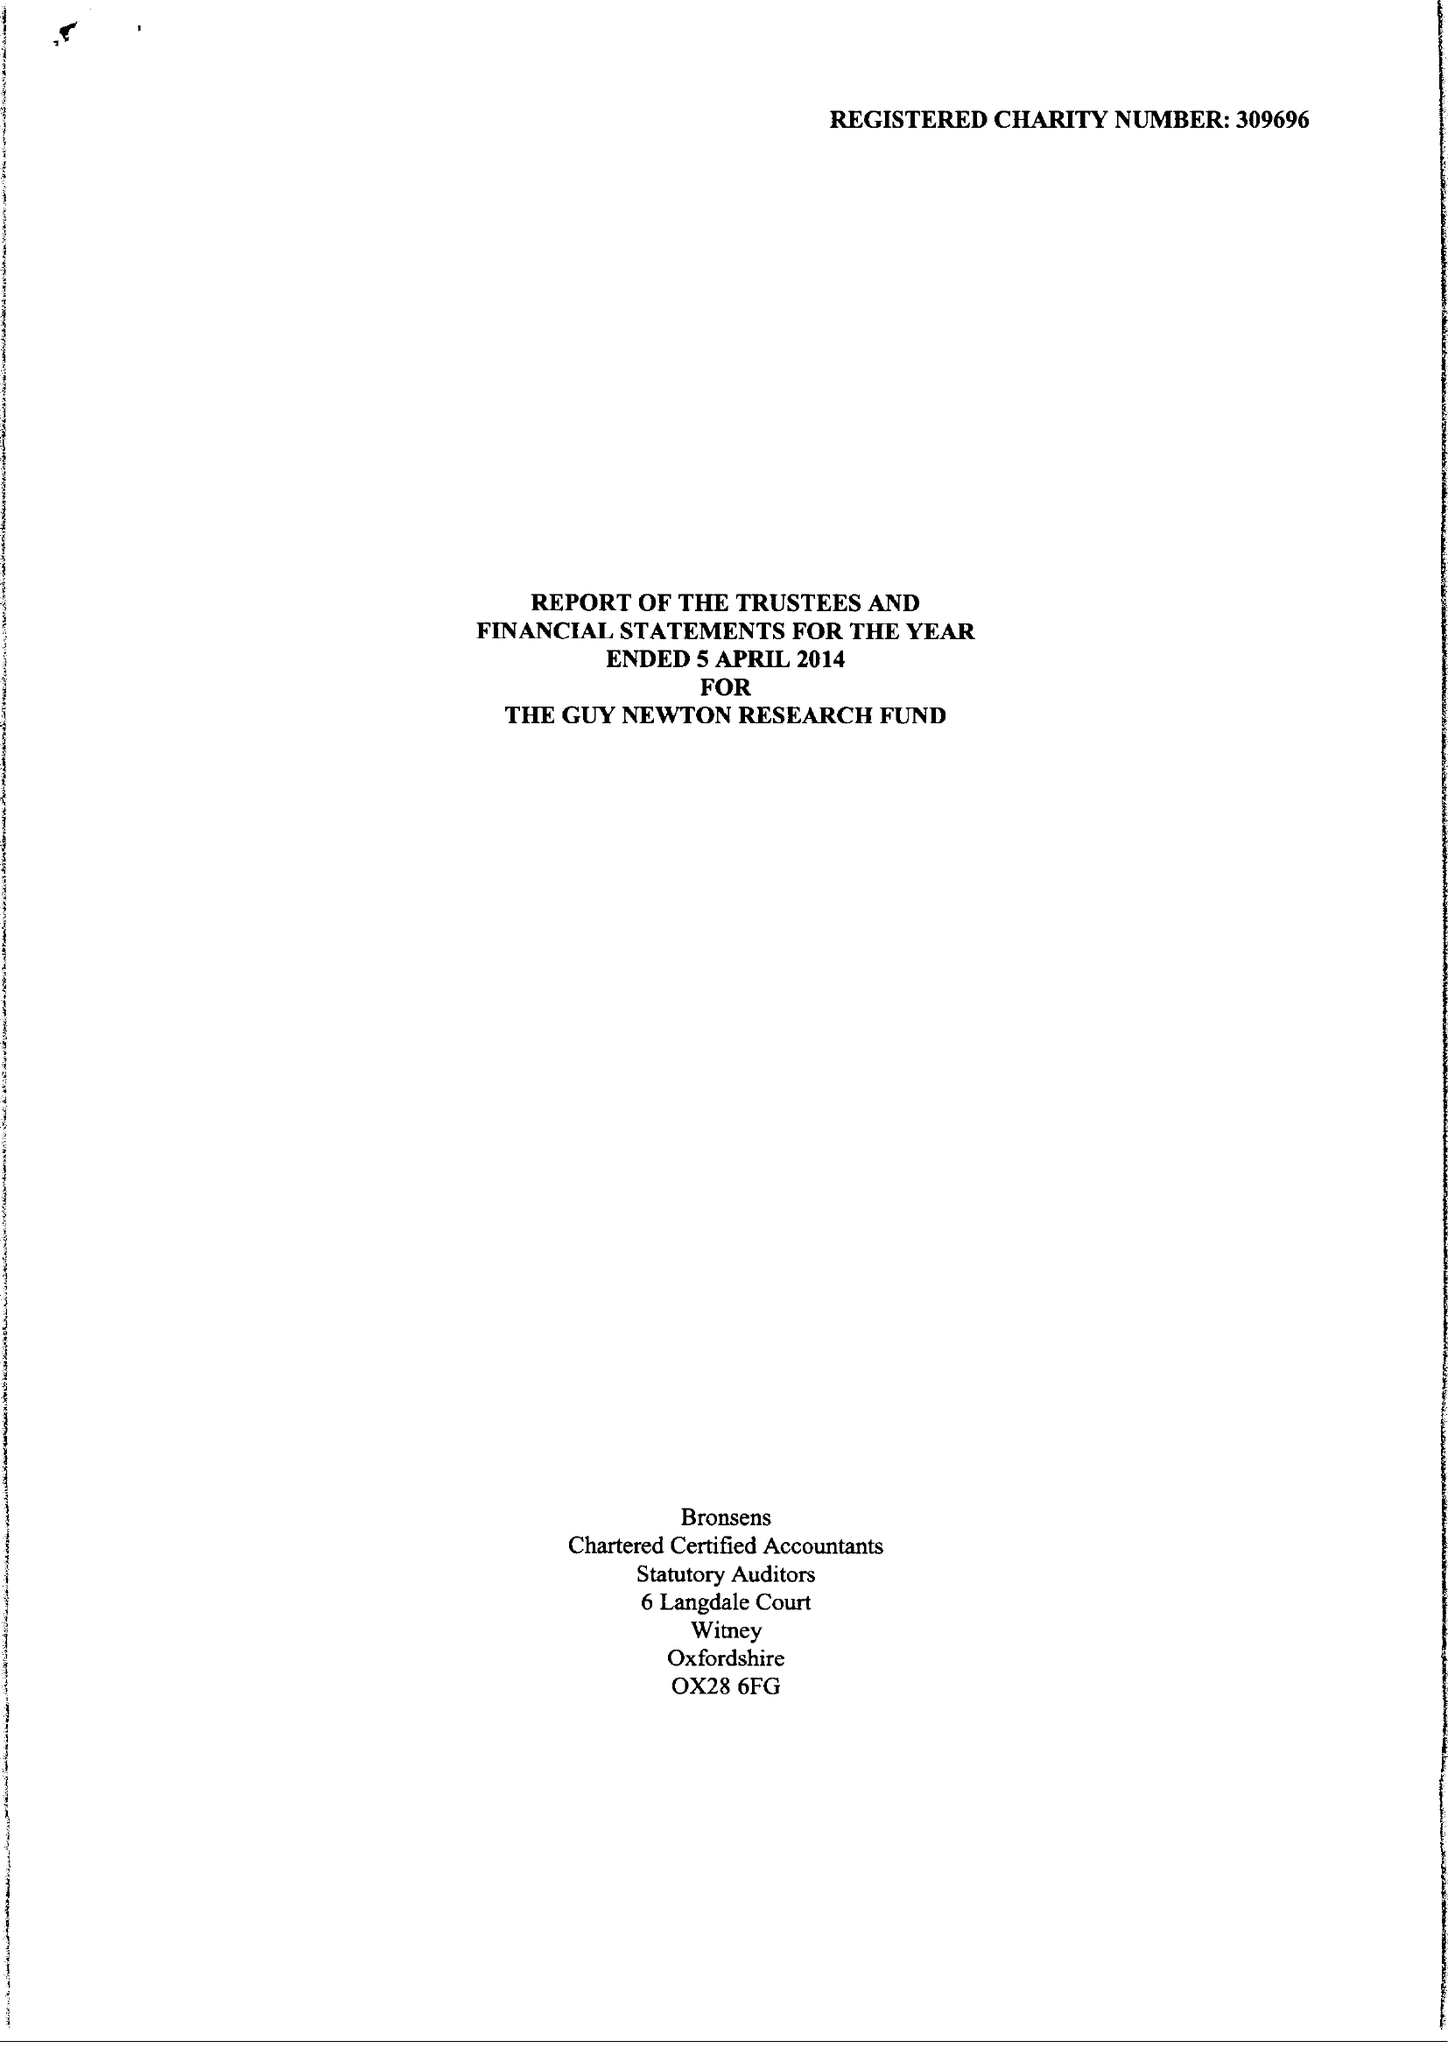What is the value for the income_annually_in_british_pounds?
Answer the question using a single word or phrase. 211472.00 